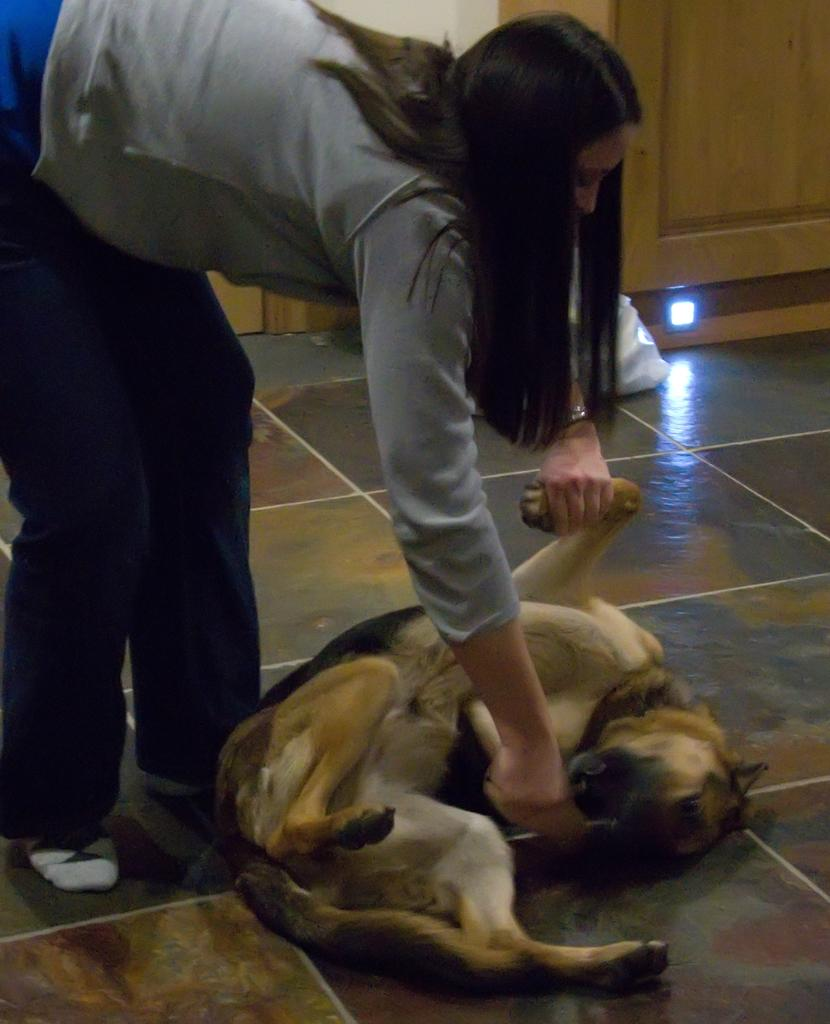Who is the main subject in the image? There is a lady in the center of the image. What is on the floor in the image? There is a dog on the floor. What can be seen in the background of the image? There is a door in the background of the image. How many babies are present in the image? There are no babies present in the image. What type of pet is the lady holding in the image? The lady is not holding any pet in the image; there is only a dog on the floor. 